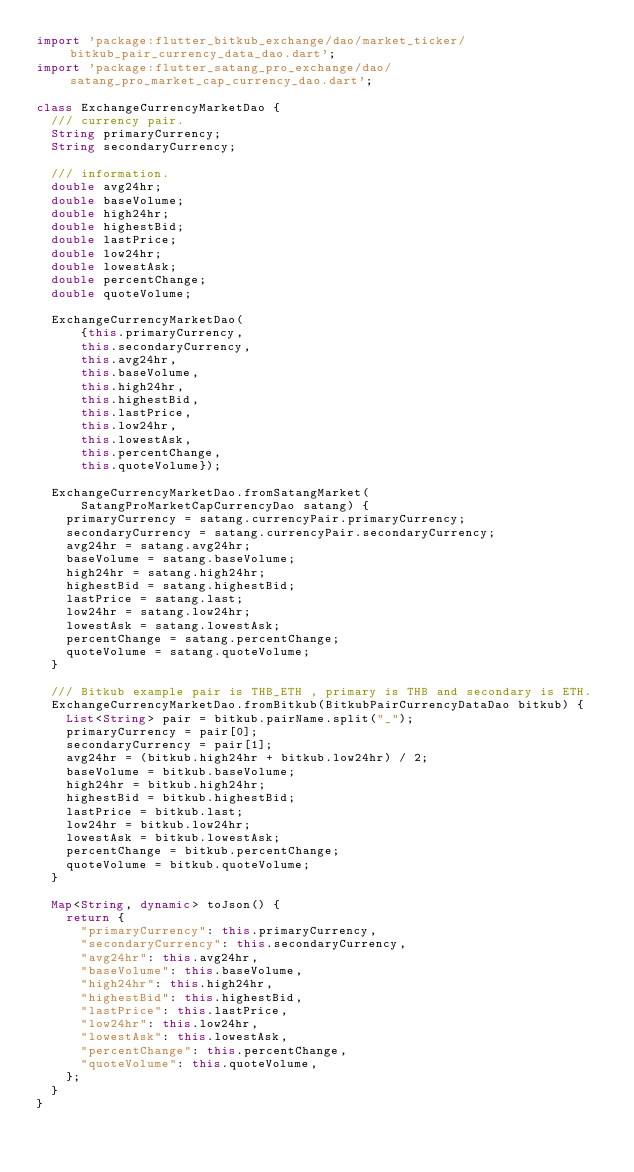Convert code to text. <code><loc_0><loc_0><loc_500><loc_500><_Dart_>import 'package:flutter_bitkub_exchange/dao/market_ticker/bitkub_pair_currency_data_dao.dart';
import 'package:flutter_satang_pro_exchange/dao/satang_pro_market_cap_currency_dao.dart';

class ExchangeCurrencyMarketDao {
  /// currency pair.
  String primaryCurrency;
  String secondaryCurrency;

  /// information.
  double avg24hr;
  double baseVolume;
  double high24hr;
  double highestBid;
  double lastPrice;
  double low24hr;
  double lowestAsk;
  double percentChange;
  double quoteVolume;

  ExchangeCurrencyMarketDao(
      {this.primaryCurrency,
      this.secondaryCurrency,
      this.avg24hr,
      this.baseVolume,
      this.high24hr,
      this.highestBid,
      this.lastPrice,
      this.low24hr,
      this.lowestAsk,
      this.percentChange,
      this.quoteVolume});

  ExchangeCurrencyMarketDao.fromSatangMarket(
      SatangProMarketCapCurrencyDao satang) {
    primaryCurrency = satang.currencyPair.primaryCurrency;
    secondaryCurrency = satang.currencyPair.secondaryCurrency;
    avg24hr = satang.avg24hr;
    baseVolume = satang.baseVolume;
    high24hr = satang.high24hr;
    highestBid = satang.highestBid;
    lastPrice = satang.last;
    low24hr = satang.low24hr;
    lowestAsk = satang.lowestAsk;
    percentChange = satang.percentChange;
    quoteVolume = satang.quoteVolume;
  }

  /// Bitkub example pair is THB_ETH , primary is THB and secondary is ETH.
  ExchangeCurrencyMarketDao.fromBitkub(BitkubPairCurrencyDataDao bitkub) {
    List<String> pair = bitkub.pairName.split("_");
    primaryCurrency = pair[0];
    secondaryCurrency = pair[1];
    avg24hr = (bitkub.high24hr + bitkub.low24hr) / 2;
    baseVolume = bitkub.baseVolume;
    high24hr = bitkub.high24hr;
    highestBid = bitkub.highestBid;
    lastPrice = bitkub.last;
    low24hr = bitkub.low24hr;
    lowestAsk = bitkub.lowestAsk;
    percentChange = bitkub.percentChange;
    quoteVolume = bitkub.quoteVolume;
  }

  Map<String, dynamic> toJson() {
    return {
      "primaryCurrency": this.primaryCurrency,
      "secondaryCurrency": this.secondaryCurrency,
      "avg24hr": this.avg24hr,
      "baseVolume": this.baseVolume,
      "high24hr": this.high24hr,
      "highestBid": this.highestBid,
      "lastPrice": this.lastPrice,
      "low24hr": this.low24hr,
      "lowestAsk": this.lowestAsk,
      "percentChange": this.percentChange,
      "quoteVolume": this.quoteVolume,
    };
  }
}
</code> 